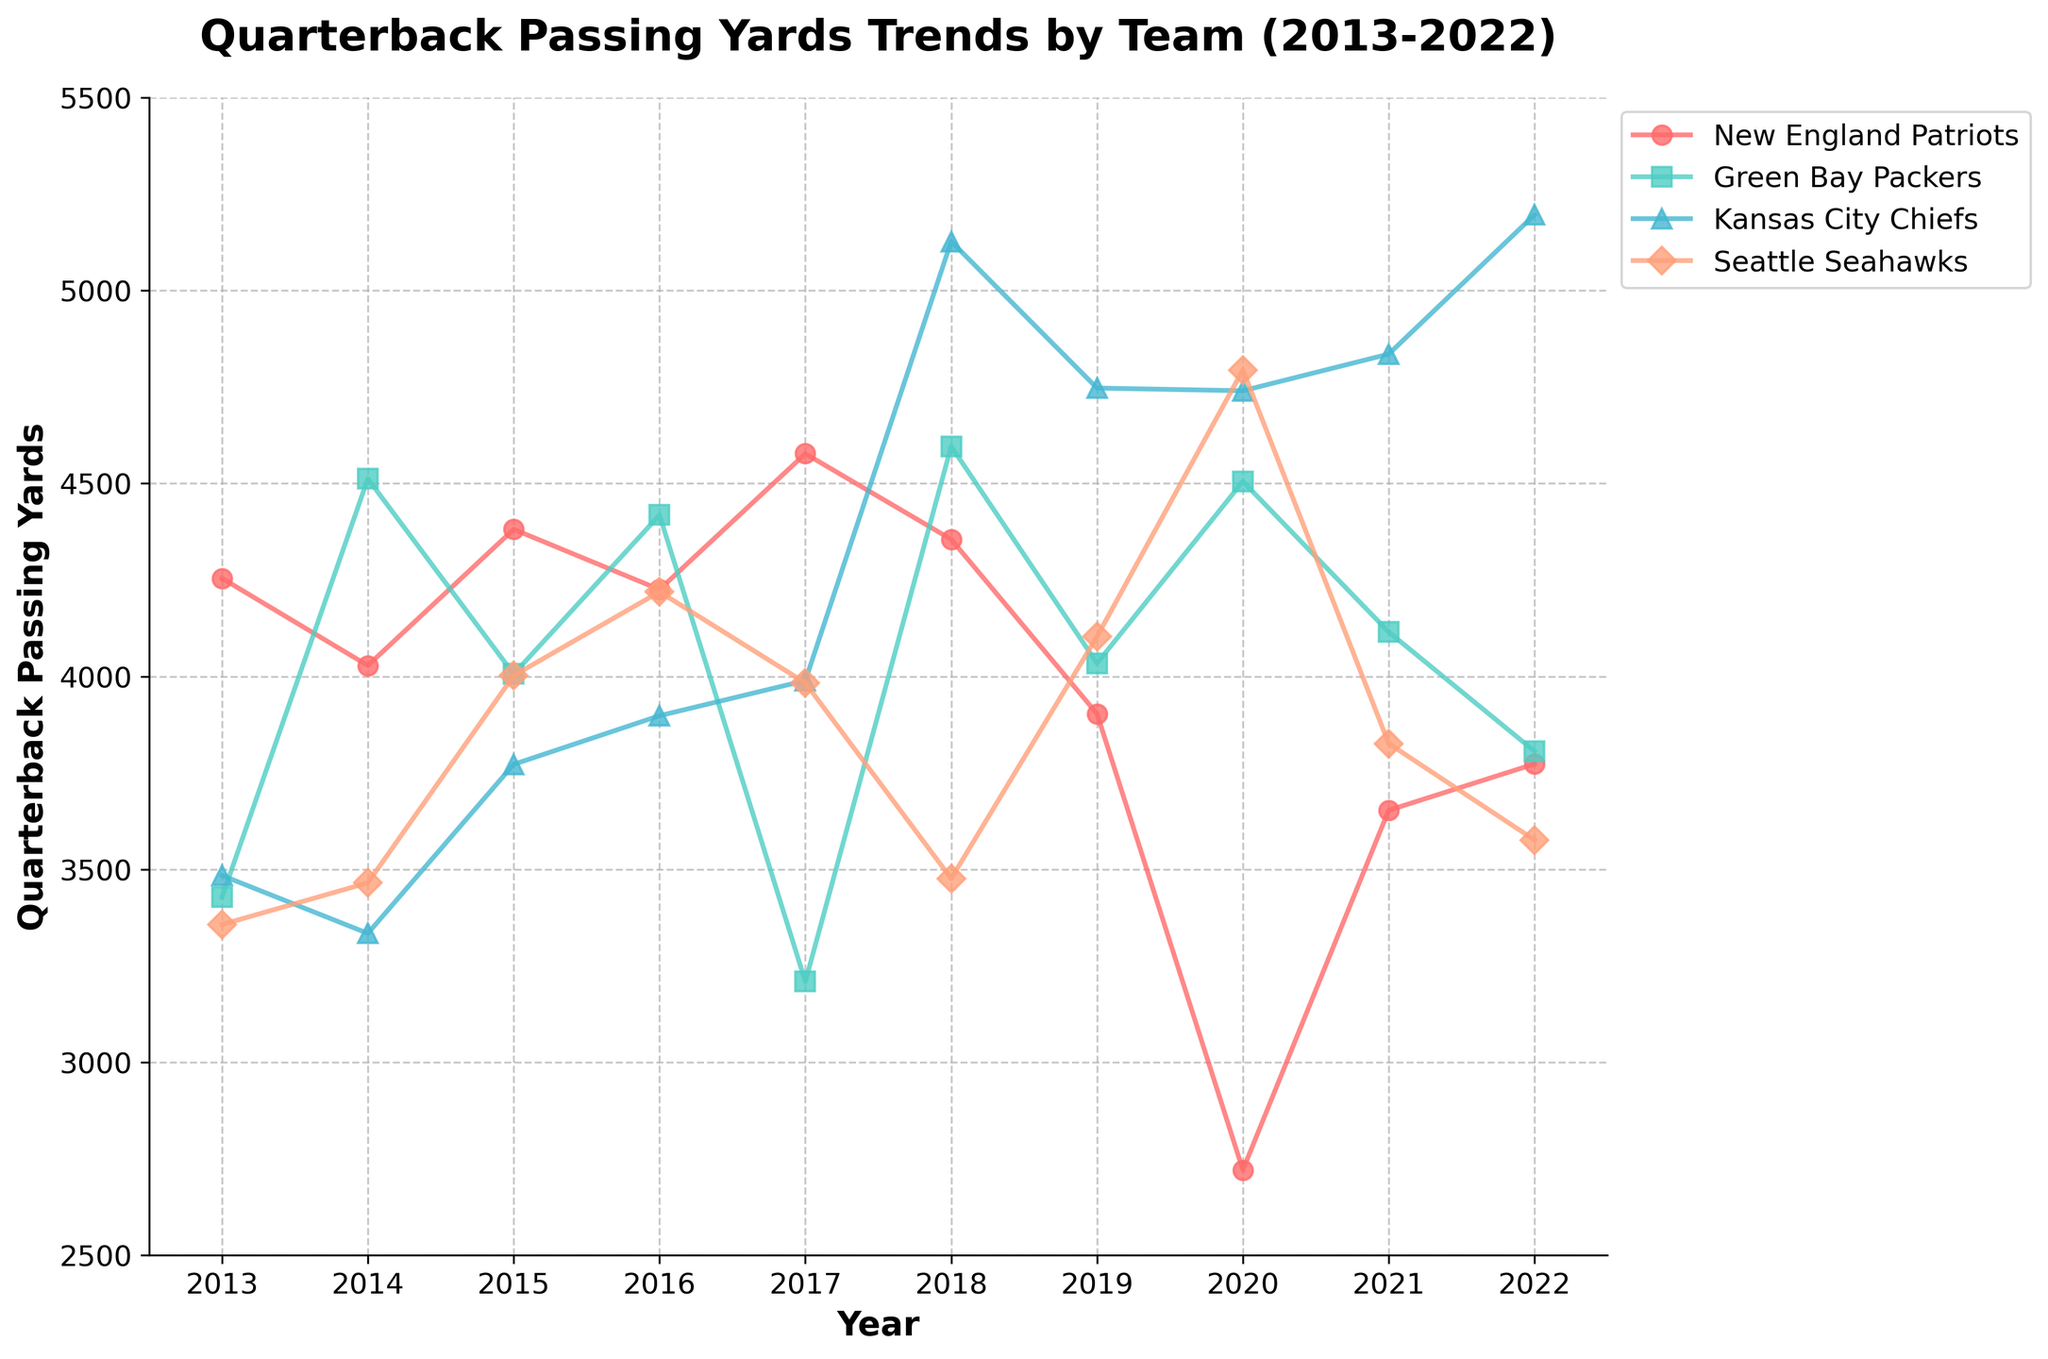what is the title of the plot? The title can be found at the top of the plot and it describes the main focus of the figure. The title for this plot is "Quarterback Passing Yards Trends by Team (2013-2022)"
Answer: Quarterback Passing Yards Trends by Team (2013-2022) Which team had the highest passing yards in 2018? To identify the team with the highest passing yards in 2018, check the 2018 markers and find the highest point. The Kansas City Chiefs had the highest passing yards in 2018, indicated at 5127.
Answer: Kansas City Chiefs What trends can you observe for the New England Patriots quarterback passing yards over the last decade? To identify trends, look at the line corresponding to the New England Patriots. Initially, there are some fluctuations with a peak in 2017, followed by a downward trend, hitting a low in 2020, then slightly recovering until 2022.
Answer: Fluctuations, peak in 2017, decline from 2017 to 2020, slight recovery until 2022 Which team showed a significant increase in quarterback passing yards between 2017 and 2018? To determine which team had a significant increase, compare the markers from 2017 to 2018 for each team. The Kansas City Chiefs showed a significant increase, jumping from 3989 yards in 2017 to 5127 yards in 2018.
Answer: Kansas City Chiefs Which team's quarterback passing yards showed the least variability over the last decade? To determine the least variability, look for the line with the smallest fluctuations. The New England Patriots had the least variability because their line shows smaller variations compared to other teams, except for the notable drop in 2020.
Answer: New England Patriots How did the Seattle Seahawks' quarterback passing yards change from 2020 to 2022? To examine the change from 2020 to 2022, observe the Seattle Seahawks' line from 2020 to 2022. The passing yards dropped significantly from 4794 in 2020 to 3826 in 2021, continuing to drop to 3576 in 2022.
Answer: Significant drop Which team had the highest quarterback passing yards average over the decade? To calculate the average passing yards for each team, sum up the passing yards for each year and divide by the number of years. The Kansas City Chiefs have a higher average due to multiple high points, including the peaks in 2018 and 2022.
Answer: Kansas City Chiefs What comparison can you make between the Green Bay Packers and New England Patriots in terms of their lowest passing yards year? Identify the lowest passing yards year for each team from the plot. The Green Bay Packers' lowest year was 2013 with 3428 yards, while the New England Patriots' lowest year was 2020 with 2721 yards.
Answer: Green Bay Packers: 2013, New England Patriots: 2020 